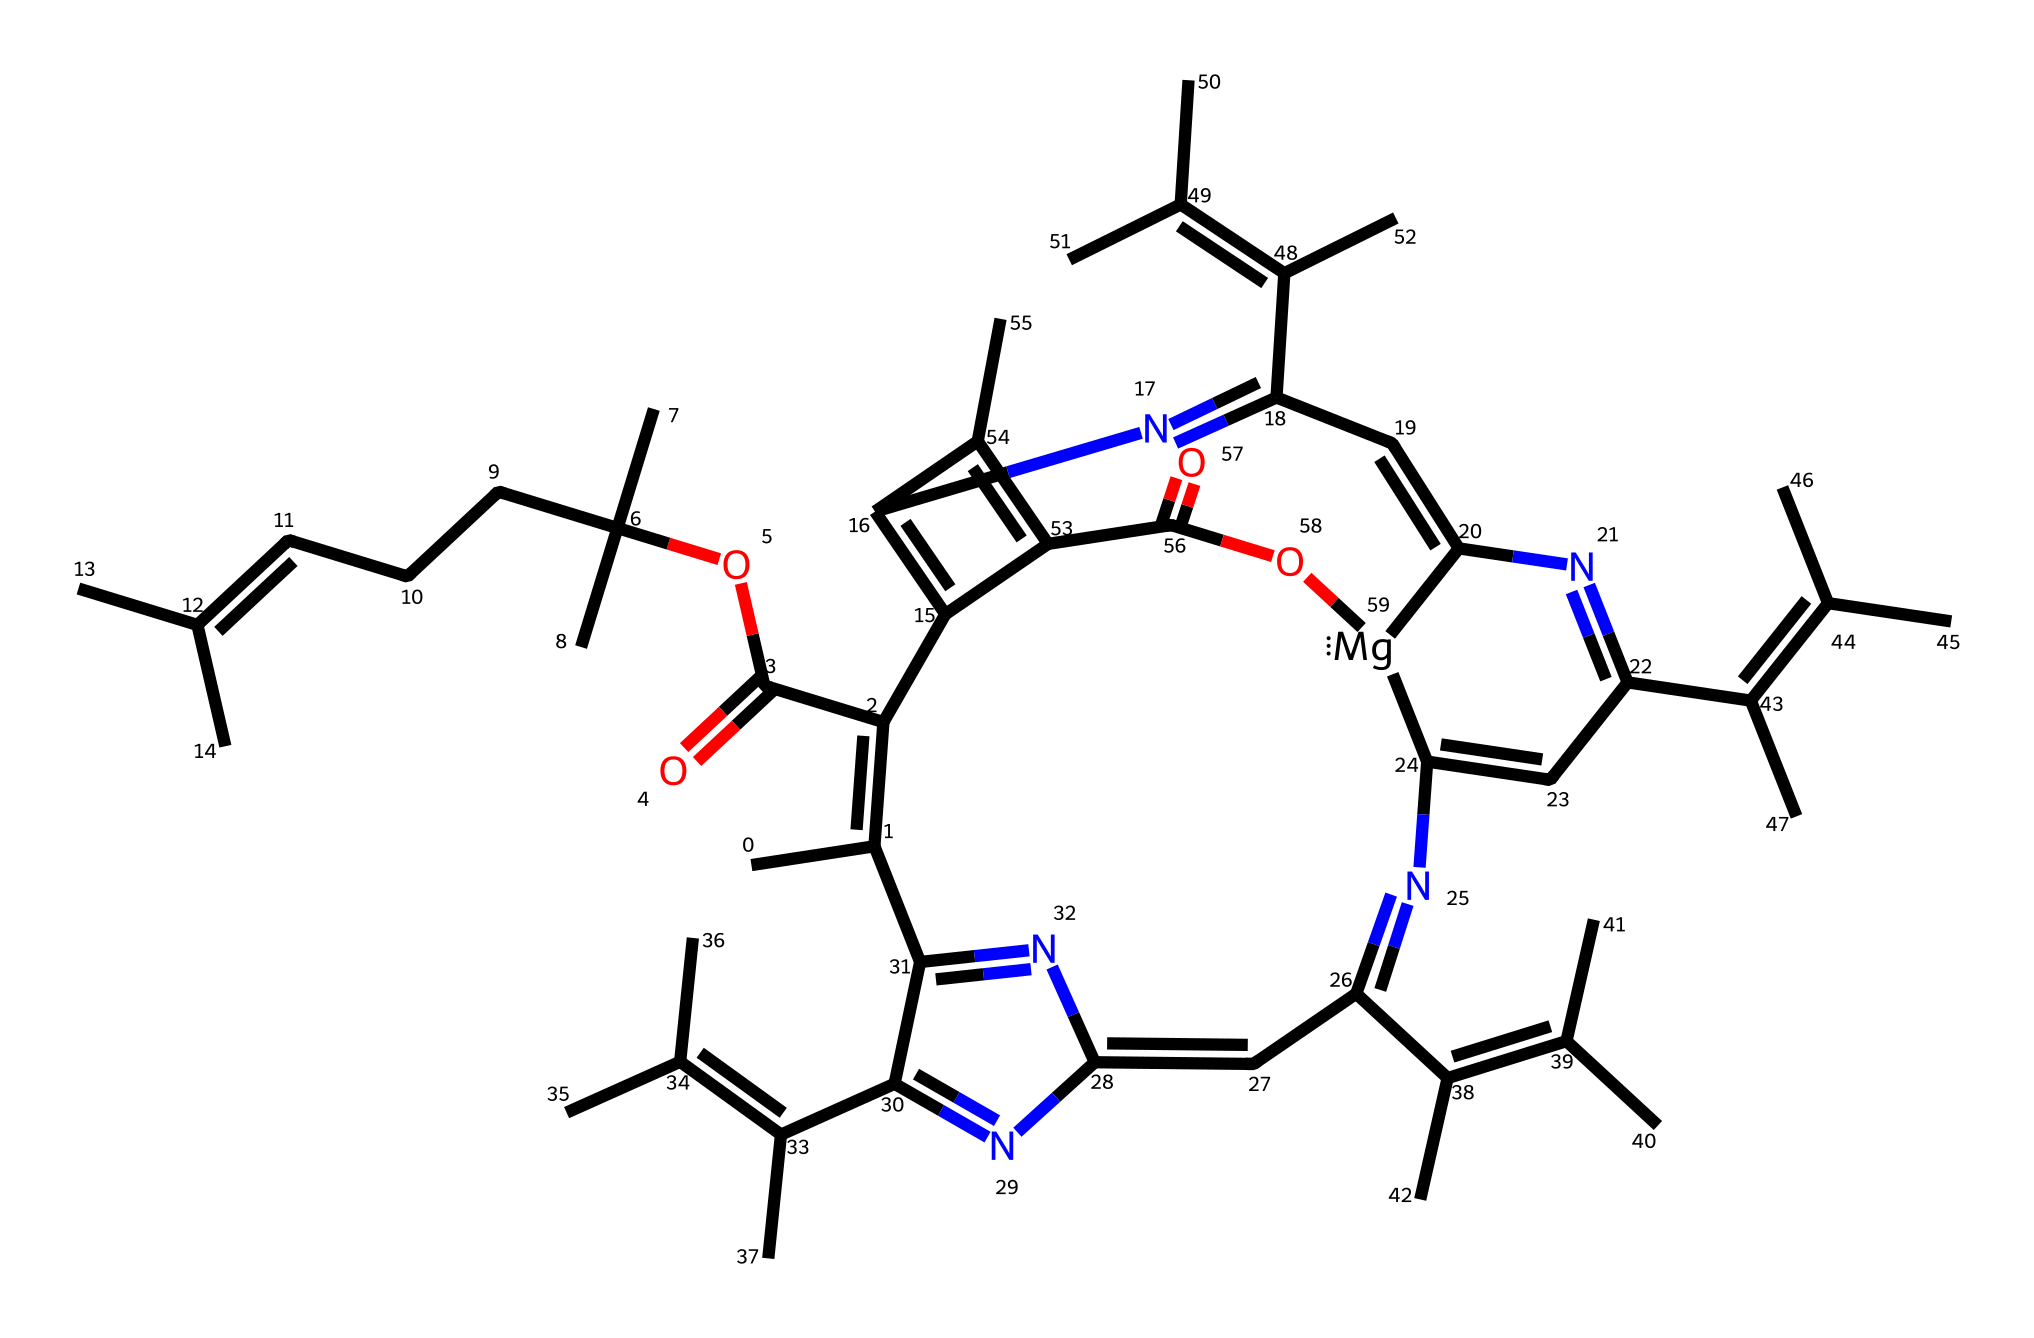What is the main metal ion present in this chlorophyll structure? The chlorophyll structure contains a central metal ion, which is indicated by the notation "[Mg]" in the SMILES representation. This signifies magnesium, which is essential for its role in photosynthesis.
Answer: magnesium How many rings are in the structure of chlorophyll? The SMILES representation reveals multiple cyclic components, and by analyzing the connections, one can count the number of distinct rings present. There are five interconnected rings in the structure.
Answer: five What are the two main functional groups present in chlorophyll? By examining the chemical structure, one can identify the functional groups. These include carboxylic acid (indicated by C(=O)O) and an ester (indicated by C(=O)OC). Both contribute to the reactivity and properties of chlorophyll.
Answer: carboxylic acid and ester What color does chlorophyll produce in plants, specifically in grass? Chlorophyll primarily absorbs blue and red light, reflecting green light, which is why grass appears green. The specific arrangement of double bonds in the structure also supports this property.
Answer: green How many total carbon atoms does this chlorophyll structure contain? Counting each 'C' in the SMILES representation helps determine the number of carbon atoms in the chlorophyll structure. Specifically, by systematically analyzing each part of the chemical, we find it contains 27 carbon atoms.
Answer: 27 